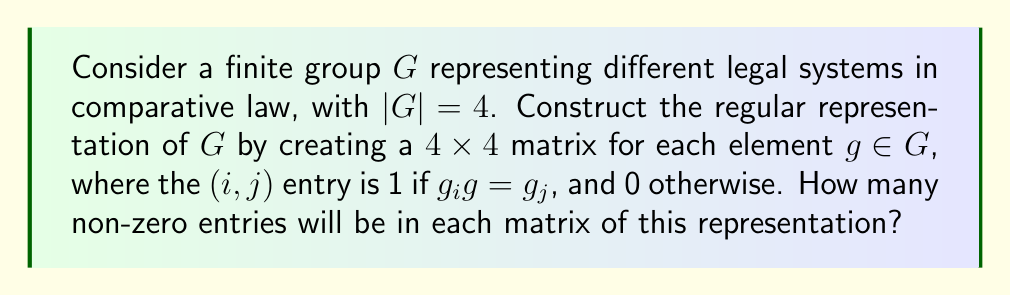Give your solution to this math problem. Let's approach this step-by-step:

1) In the regular representation, each element of the group is represented by a permutation matrix.

2) For a group $G$ of order 4, we will have 4x4 matrices.

3) In each row and each column of these matrices, there will be exactly one 1, and the rest will be 0s. This is because:
   - For each $g_i$, there is exactly one $g_j$ such that $g_i g = g_j$
   - Each $g_j$ is the result of $g_i g = g_j$ for exactly one $g_i$

4) This property holds regardless of the specific structure of the group $G$, whether it represents common law, civil law, religious law, or mixed legal systems.

5) Since there are 4 rows in each matrix, and each row has exactly one 1, the total number of 1s (non-zero entries) in each matrix will be 4.

This construction allows us to represent the action of each legal system (represented by a group element) on the set of all legal systems in our comparative law model.
Answer: 4 